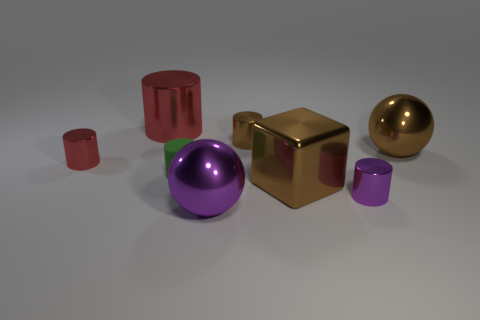There is a big ball in front of the red shiny cylinder on the left side of the large metal cylinder; what is it made of?
Offer a terse response. Metal. There is a large thing on the left side of the big purple shiny object; is it the same shape as the purple object left of the small brown metal cylinder?
Provide a succinct answer. No. Are there the same number of green cylinders to the right of the small red cylinder and metal cylinders?
Ensure brevity in your answer.  No. There is a big sphere that is behind the big purple shiny sphere; are there any purple metal balls that are to the right of it?
Offer a terse response. No. Is there anything else that has the same color as the large metallic cube?
Your answer should be compact. Yes. Are the small cylinder left of the big metal cylinder and the large brown ball made of the same material?
Offer a very short reply. Yes. Are there the same number of red cylinders right of the brown cube and small purple shiny things that are to the right of the big brown metallic ball?
Offer a terse response. Yes. What is the size of the brown thing that is in front of the ball that is behind the large brown cube?
Your answer should be very brief. Large. What material is the thing that is in front of the large cube and to the left of the tiny purple object?
Ensure brevity in your answer.  Metal. What number of other things are the same size as the brown metal cylinder?
Ensure brevity in your answer.  3. 